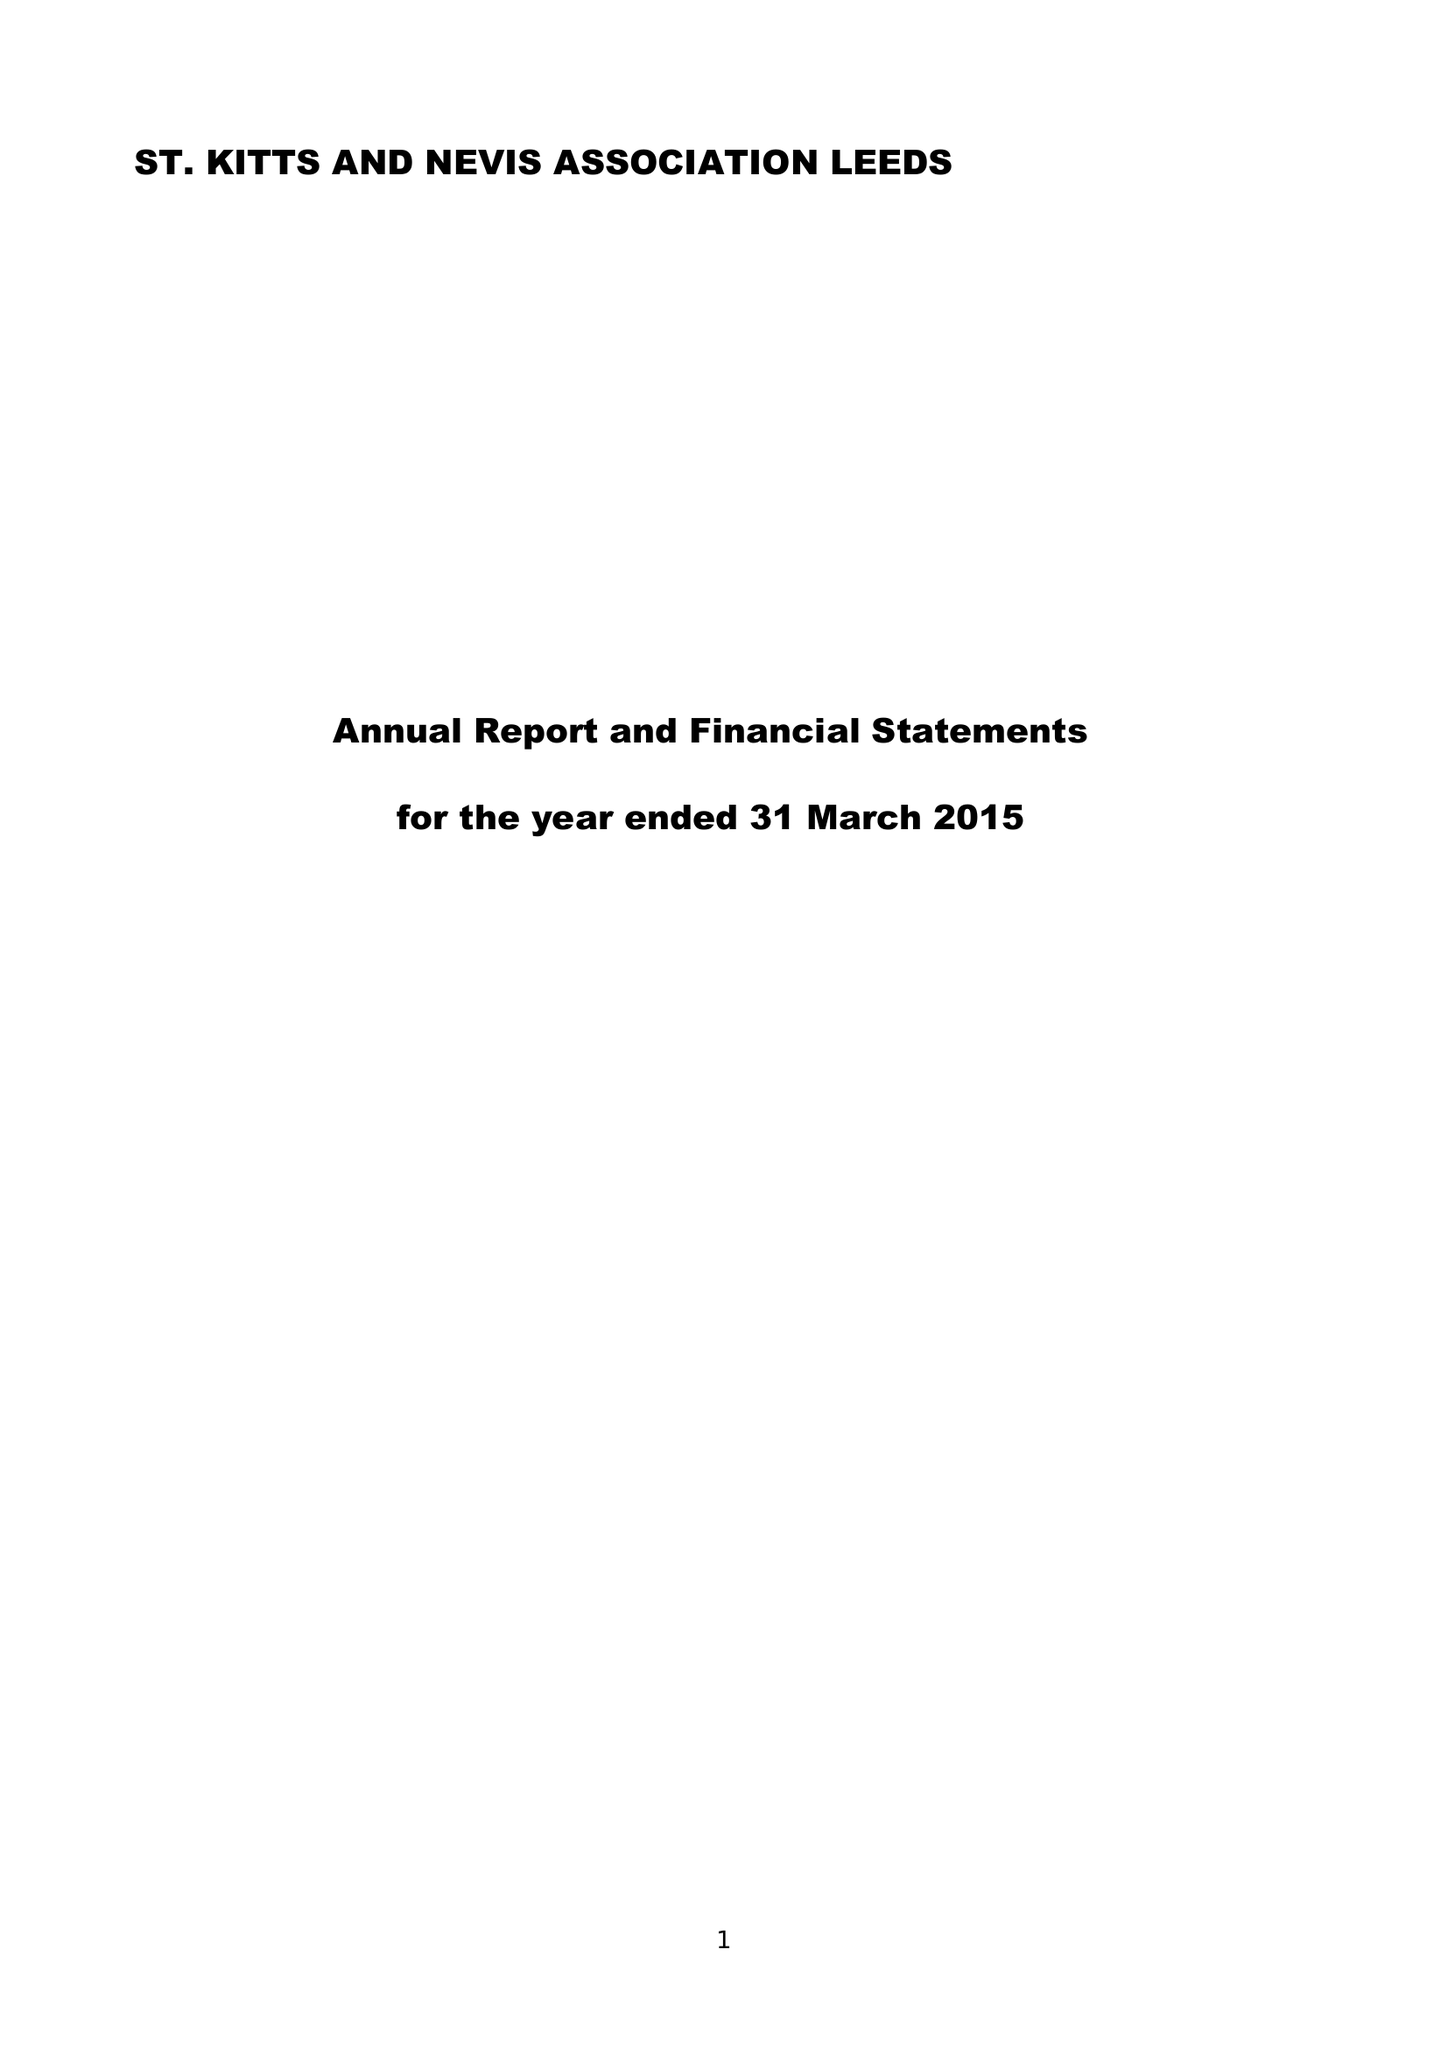What is the value for the charity_number?
Answer the question using a single word or phrase. 1026387 